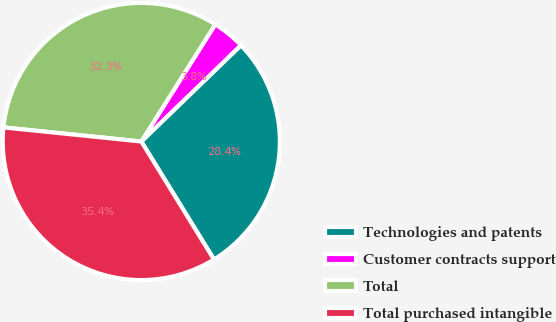Convert chart to OTSL. <chart><loc_0><loc_0><loc_500><loc_500><pie_chart><fcel>Technologies and patents<fcel>Customer contracts support<fcel>Total<fcel>Total purchased intangible<nl><fcel>28.44%<fcel>3.81%<fcel>32.34%<fcel>35.41%<nl></chart> 